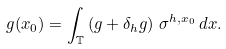Convert formula to latex. <formula><loc_0><loc_0><loc_500><loc_500>g ( x _ { 0 } ) = \int _ { \mathbb { T } } \left ( g + \delta _ { h } g \right ) \, \sigma ^ { h , x _ { 0 } } \, d x .</formula> 